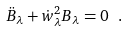Convert formula to latex. <formula><loc_0><loc_0><loc_500><loc_500>\ddot { B } _ { \lambda } + \dot { w } _ { \lambda } ^ { 2 } B _ { \lambda } = 0 \ .</formula> 